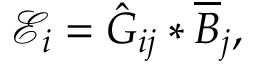Convert formula to latex. <formula><loc_0><loc_0><loc_500><loc_500>\mathcal { E } _ { i } = \hat { G } _ { i j } * \overline { B } _ { j } ,</formula> 